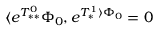Convert formula to latex. <formula><loc_0><loc_0><loc_500><loc_500>\langle e ^ { T _ { * * } ^ { 0 } } \Phi _ { 0 } , e ^ { T _ { * } ^ { 1 } \rangle \Phi _ { 0 } } = 0</formula> 